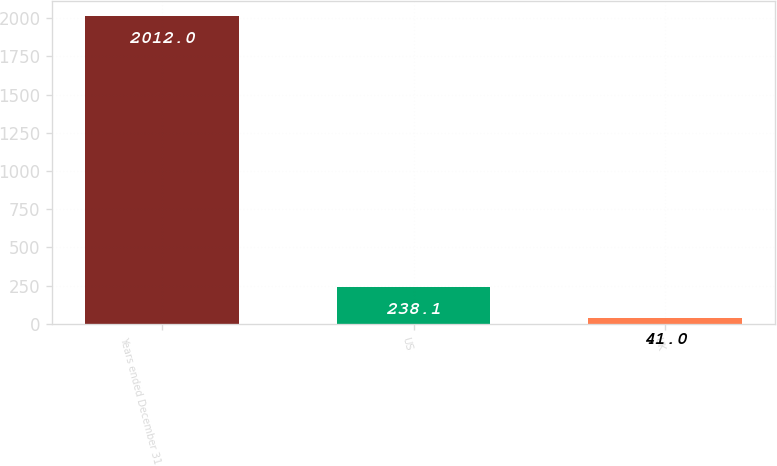<chart> <loc_0><loc_0><loc_500><loc_500><bar_chart><fcel>Years ended December 31<fcel>US<fcel>UK<nl><fcel>2012<fcel>238.1<fcel>41<nl></chart> 